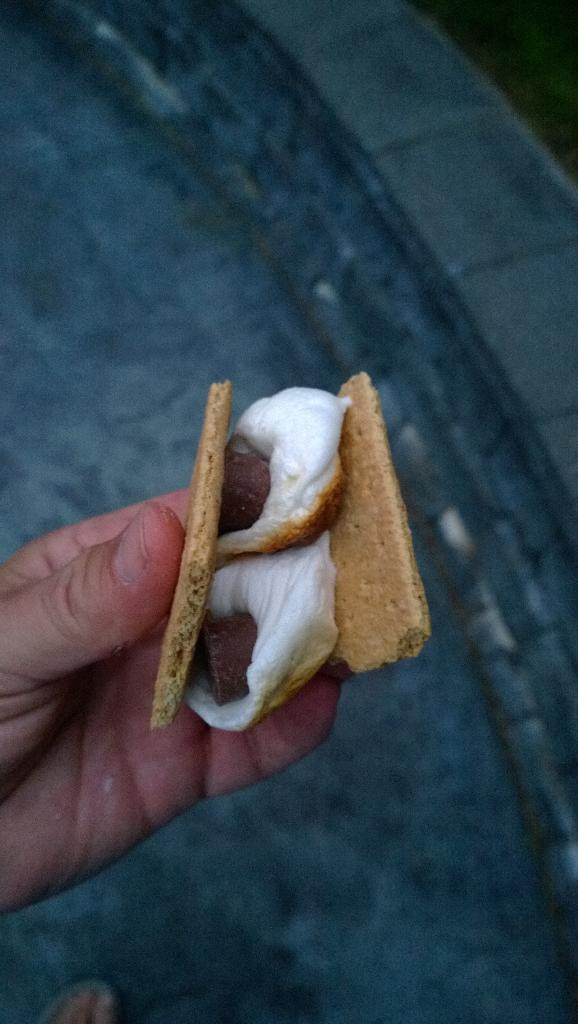Who or what is the main subject in the image? There is a person in the image. What is the person doing in the image? The person is holding food in their hand. Where is the food located in relation to the person? The food is in the center of the image. What verse can be heard being recited by the person in the image? There is no indication in the image that the person is reciting a verse, so it cannot be determined from the picture. 